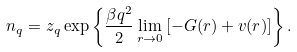Convert formula to latex. <formula><loc_0><loc_0><loc_500><loc_500>n _ { q } = z _ { q } \exp \left \{ \frac { \beta q ^ { 2 } } { 2 } \lim _ { r \to 0 } \left [ - G ( r ) + v ( r ) \right ] \right \} .</formula> 